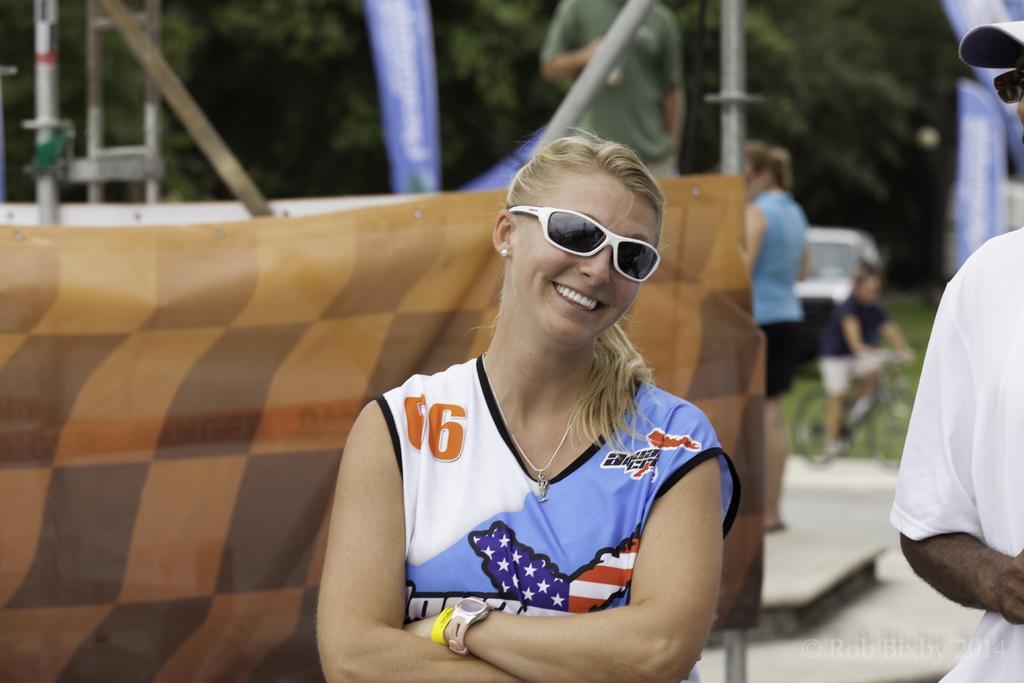Could you give a brief overview of what you see in this image? In this image, I can see two persons standing. Behind the two persons, I can see the banners, poles, a ladder, trees, two persons standing, a vehicle and a person riding bicycle. In the bottom right corner of the image, there is a watermark. 